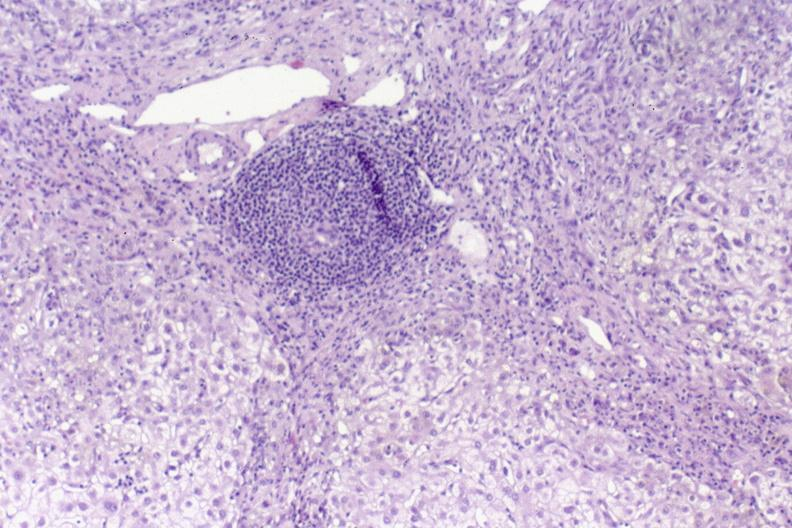s liver present?
Answer the question using a single word or phrase. Yes 